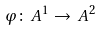<formula> <loc_0><loc_0><loc_500><loc_500>\varphi \colon \, A ^ { 1 } \to \, A ^ { 2 }</formula> 